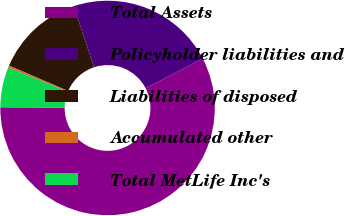<chart> <loc_0><loc_0><loc_500><loc_500><pie_chart><fcel>Total Assets<fcel>Policyholder liabilities and<fcel>Liabilities of disposed<fcel>Accumulated other<fcel>Total MetLife Inc's<nl><fcel>57.71%<fcel>22.49%<fcel>13.43%<fcel>0.31%<fcel>6.05%<nl></chart> 